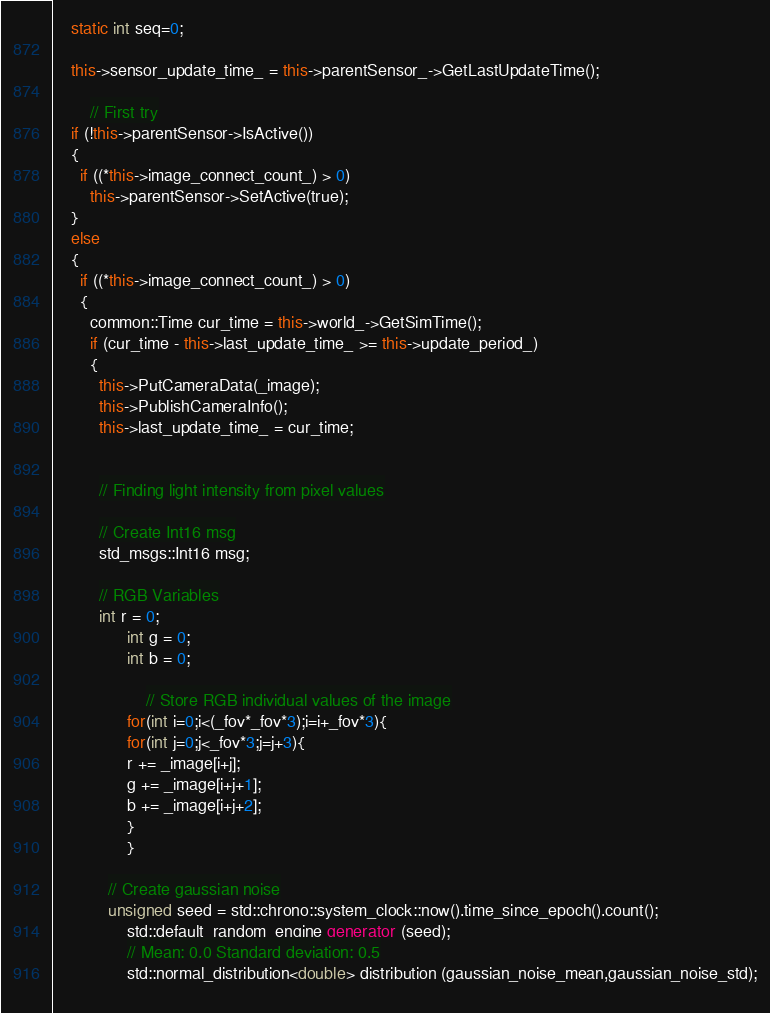Convert code to text. <code><loc_0><loc_0><loc_500><loc_500><_C++_>    static int seq=0;

    this->sensor_update_time_ = this->parentSensor_->GetLastUpdateTime();
    
		// First try
    if (!this->parentSensor->IsActive())
    {
      if ((*this->image_connect_count_) > 0)
        this->parentSensor->SetActive(true);
    }
    else
    {
      if ((*this->image_connect_count_) > 0)
      {
        common::Time cur_time = this->world_->GetSimTime();
        if (cur_time - this->last_update_time_ >= this->update_period_)
        {
          this->PutCameraData(_image);
          this->PublishCameraInfo();
          this->last_update_time_ = cur_time;
          
          
          // Finding light intensity from pixel values
          
          // Create Int16 msg
          std_msgs::Int16 msg;
          
          // RGB Variables
          int r = 0;
    			int g = 0;
    			int b = 0;

					// Store RGB individual values of the image
    			for(int i=0;i<(_fov*_fov*3);i=i+_fov*3){
        		for(int j=0;j<_fov*3;j=j+3){
            	r += _image[i+j];
            	g += _image[i+j+1];
            	b += _image[i+j+2];
        		}
    			}
         	
         	// Create gaussian noise
         	unsigned seed = std::chrono::system_clock::now().time_since_epoch().count();
  				std::default_random_engine generator (seed);
  				// Mean: 0.0 Standard deviation: 0.5
  				std::normal_distribution<double> distribution (gaussian_noise_mean,gaussian_noise_std);
         	</code> 